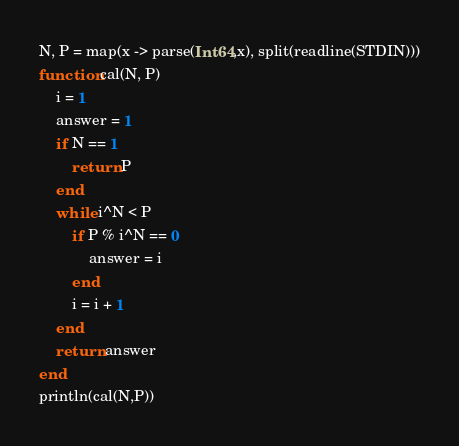<code> <loc_0><loc_0><loc_500><loc_500><_Julia_>N, P = map(x -> parse(Int64,x), split(readline(STDIN)))
function cal(N, P)
    i = 1
    answer = 1
    if N == 1
        return P
    end
    while i^N < P
        if P % i^N == 0
            answer = i
        end
        i = i + 1
    end
    return answer
end
println(cal(N,P))</code> 